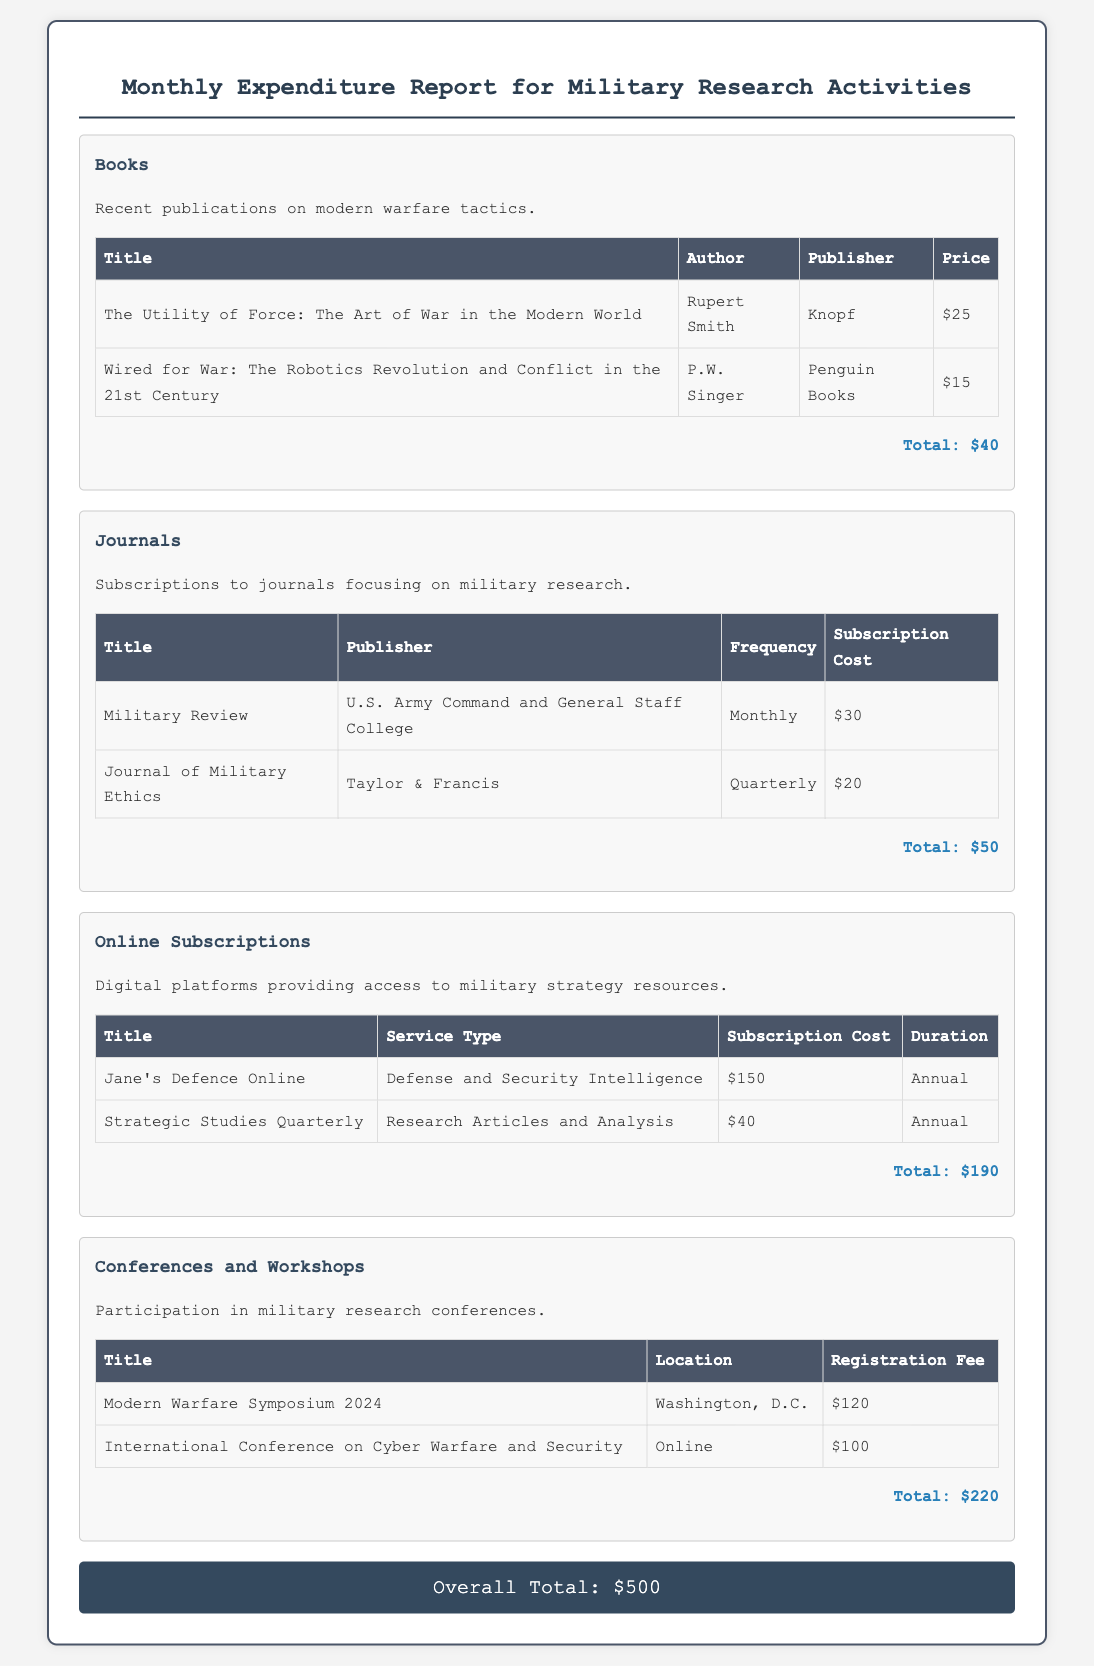What is the total cost for books? The total cost for books is calculated based on the prices listed for each title, which sum to $40.
Answer: $40 How many journals are listed in the report? The report contains two journals, as indicated in the table under the Journals section.
Answer: 2 What is the subscription cost for Jane's Defence Online? The subscription cost for Jane's Defence Online is specified in the table as $150.
Answer: $150 Which event has the highest registration fee? The event with the highest registration fee is found by comparing the fees listed; the Modern Warfare Symposium 2024 costs $120.
Answer: Modern Warfare Symposium 2024 What is the overall total expenditure? The overall total expenditure is presented at the end of the document as $500, which is the sum of all expenditure items.
Answer: $500 Which book is authored by P.W. Singer? The book authored by P.W. Singer is listed under the Books section, "Wired for War: The Robotics Revolution and Conflict in the 21st Century."
Answer: Wired for War: The Robotics Revolution and Conflict in the 21st Century What type of service does Strategic Studies Quarterly provide? The service type for Strategic Studies Quarterly is defined in the table as "Research Articles and Analysis."
Answer: Research Articles and Analysis Which publisher is associated with the Journal of Military Ethics? The Journal of Military Ethics is published by Taylor & Francis, as indicated in the journal subscriptions table.
Answer: Taylor & Francis 